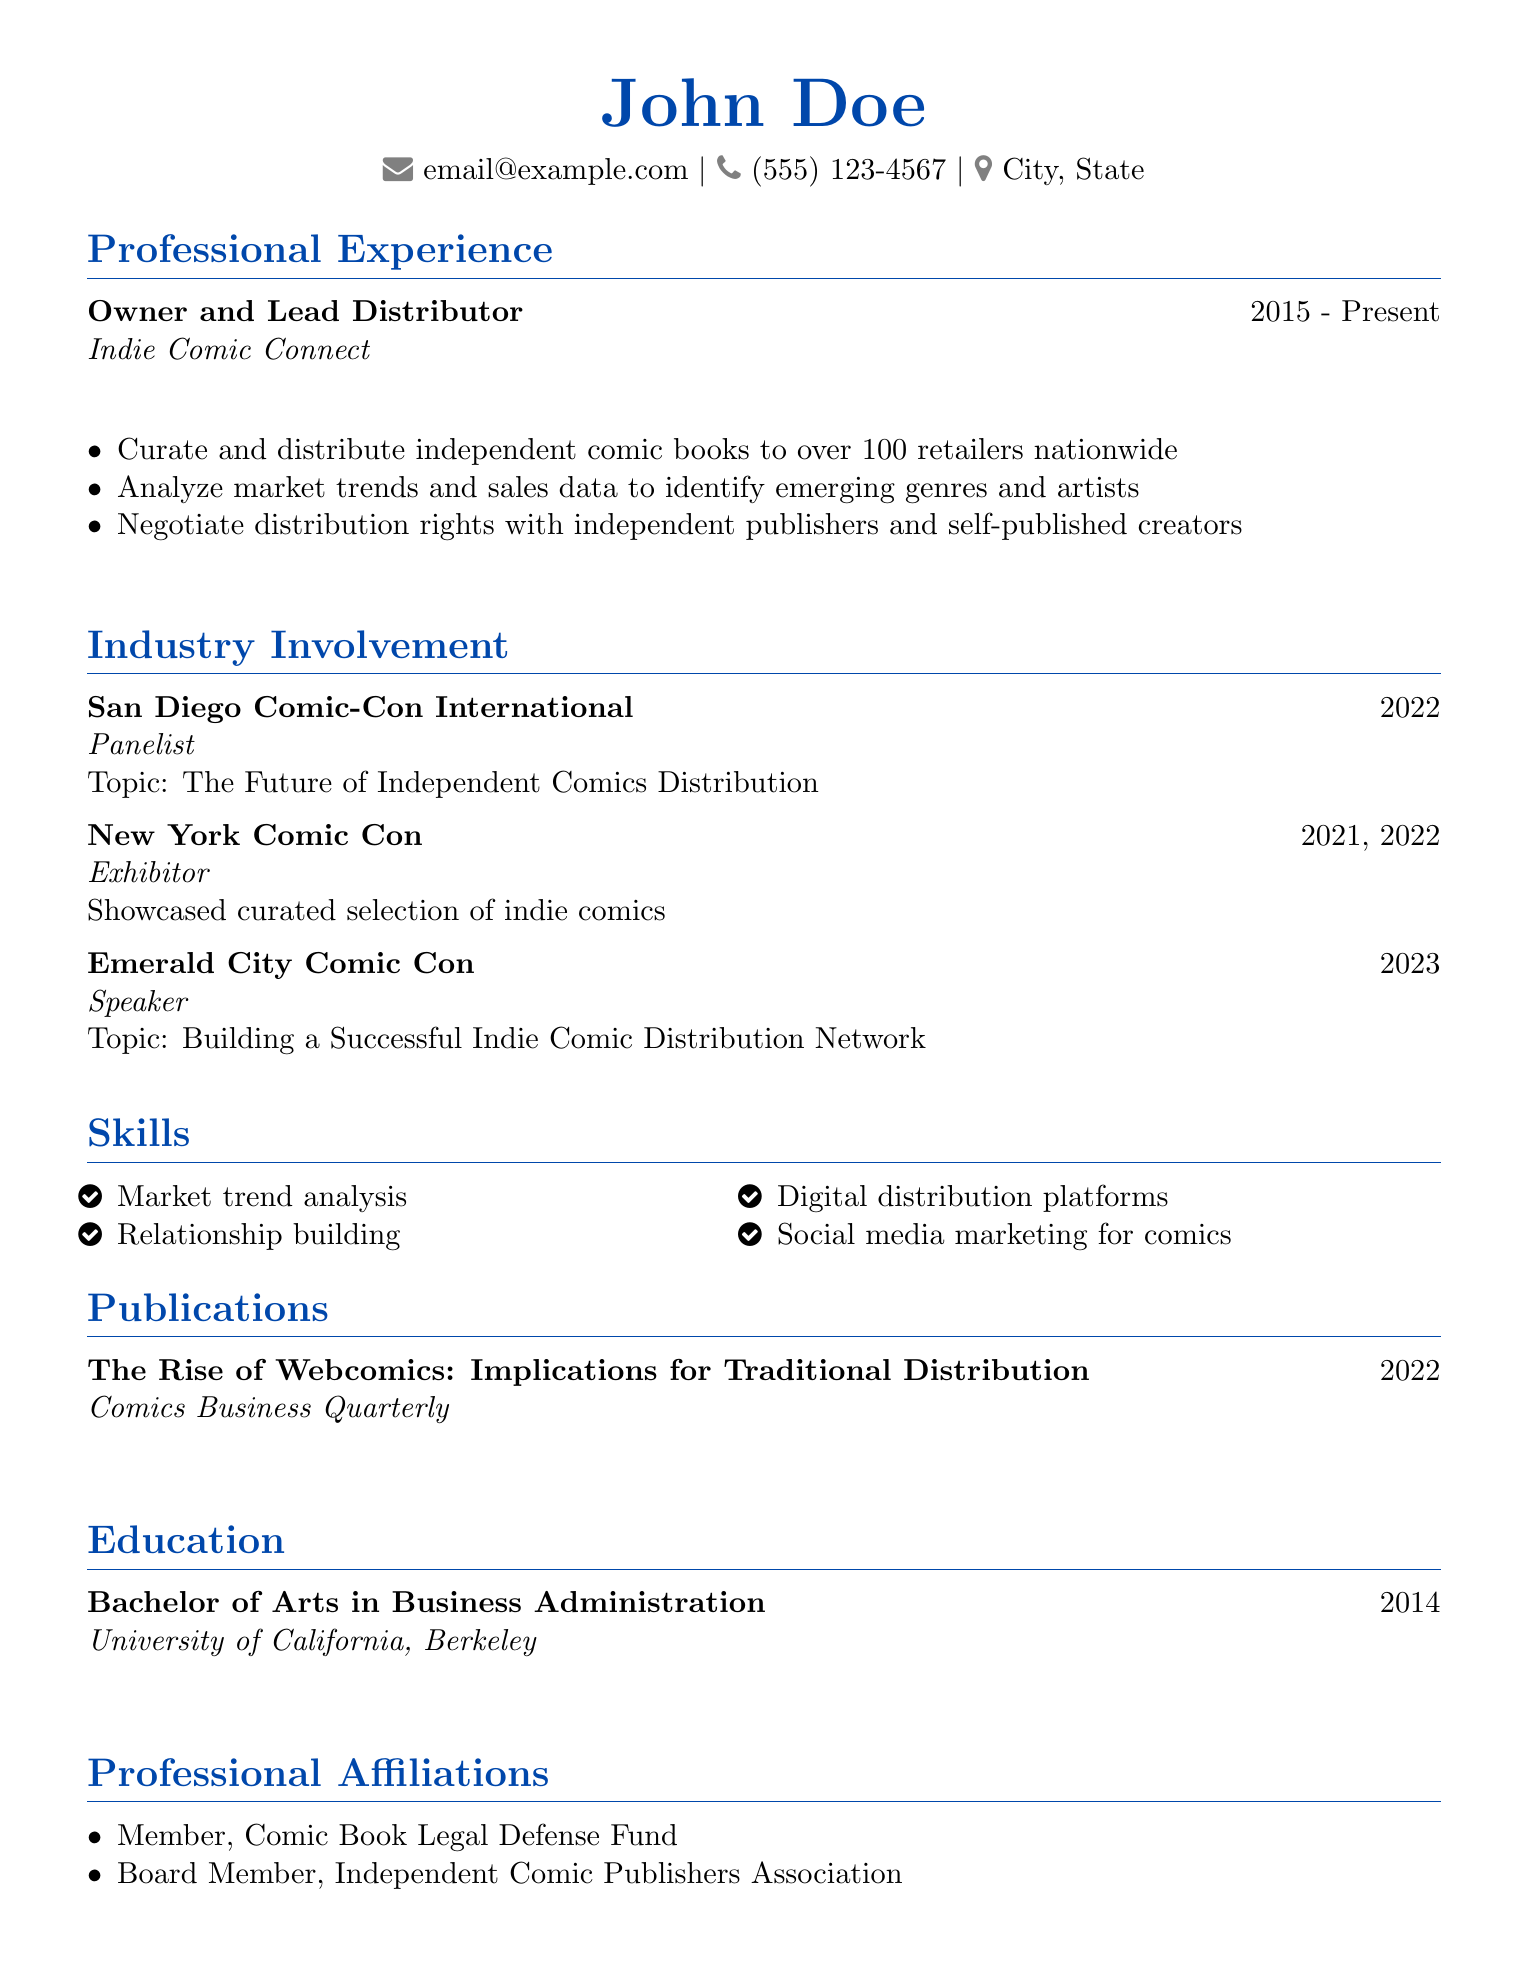what is the title of the current position? The title of the current position listed in the document is "Owner and Lead Distributor."
Answer: Owner and Lead Distributor which company is mentioned for professional experience? The document lists "Indie Comic Connect" as the company for professional experience.
Answer: Indie Comic Connect how many retailers does the distributor curate for? The document states the distributor curates for over 100 retailers nationwide.
Answer: over 100 what was the topic of the panel discussion in 2022? The topic of the panel discussion in 2022 at San Diego Comic-Con is "The Future of Independent Comics Distribution."
Answer: The Future of Independent Comics Distribution which convention was attended as an Exhibitor in 2021? The document indicates that New York Comic Con was attended as an Exhibitor in 2021.
Answer: New York Comic Con in what year did the Distributor graduate? The document states that the distributor graduated in 2014.
Answer: 2014 who is a board member of the Independent Comic Publishers Association? The resume indicates that the person listed is a Board Member of the Independent Comic Publishers Association.
Answer: Board Member what is one skill highlighted in the resume? The resume highlights several skills, including "Market trend analysis."
Answer: Market trend analysis when was the publication about webcomics published? The document lists the publication date of "The Rise of Webcomics" as 2022.
Answer: 2022 